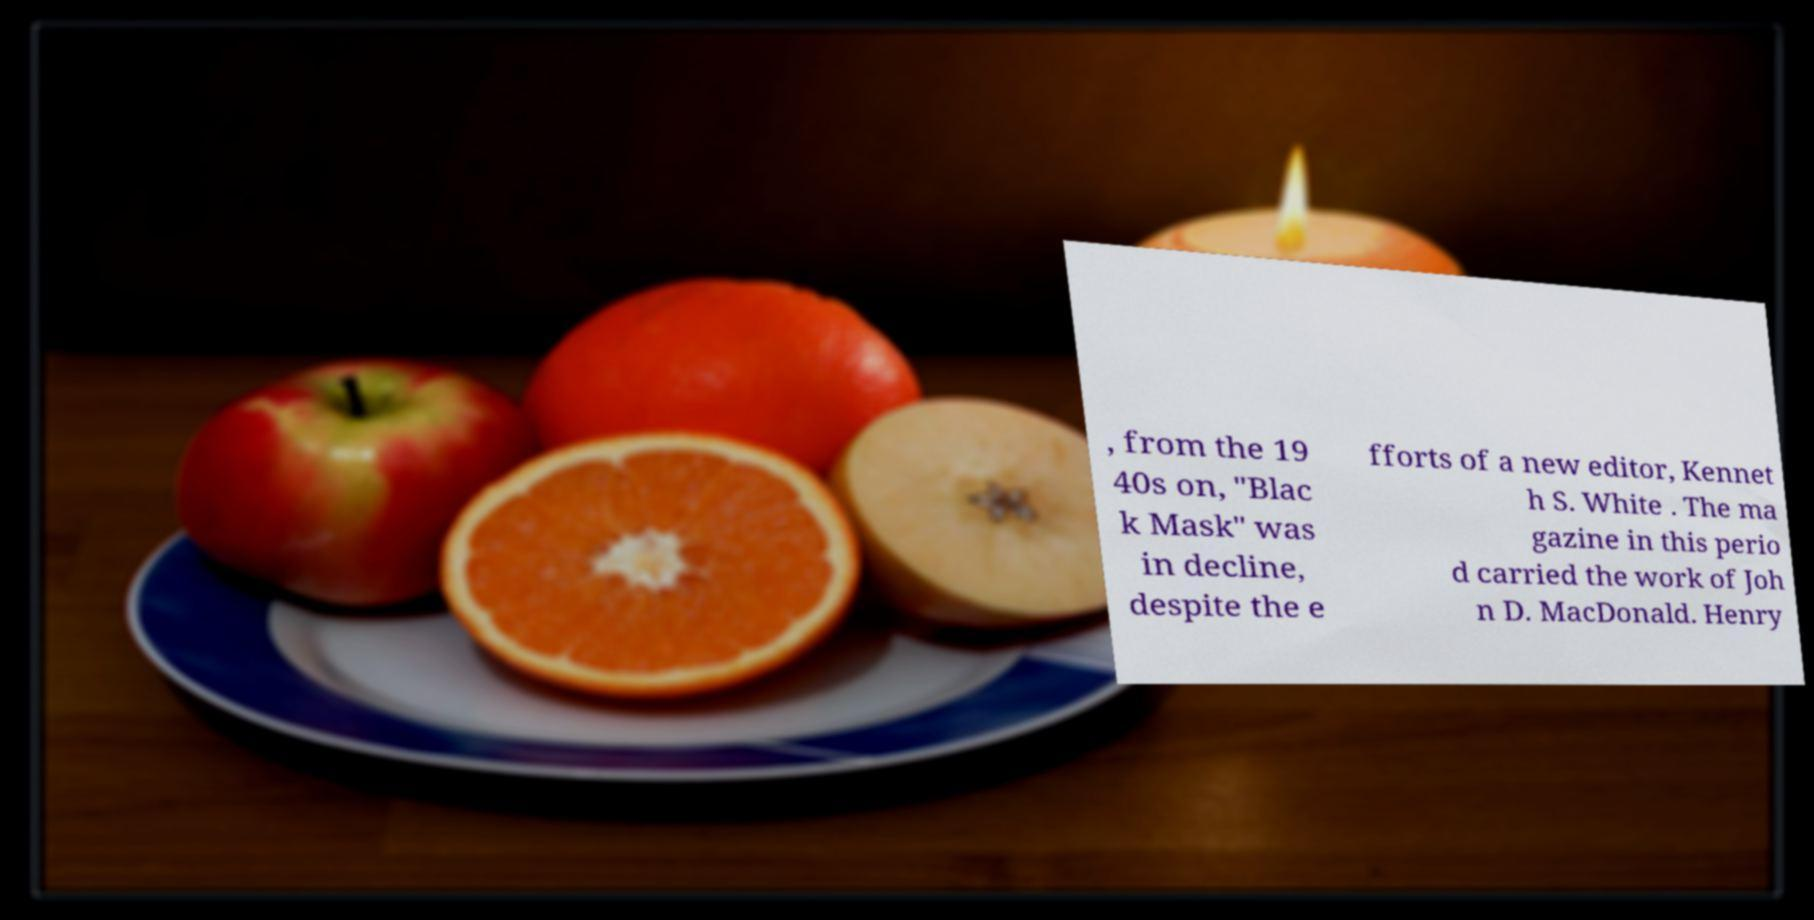I need the written content from this picture converted into text. Can you do that? , from the 19 40s on, "Blac k Mask" was in decline, despite the e fforts of a new editor, Kennet h S. White . The ma gazine in this perio d carried the work of Joh n D. MacDonald. Henry 